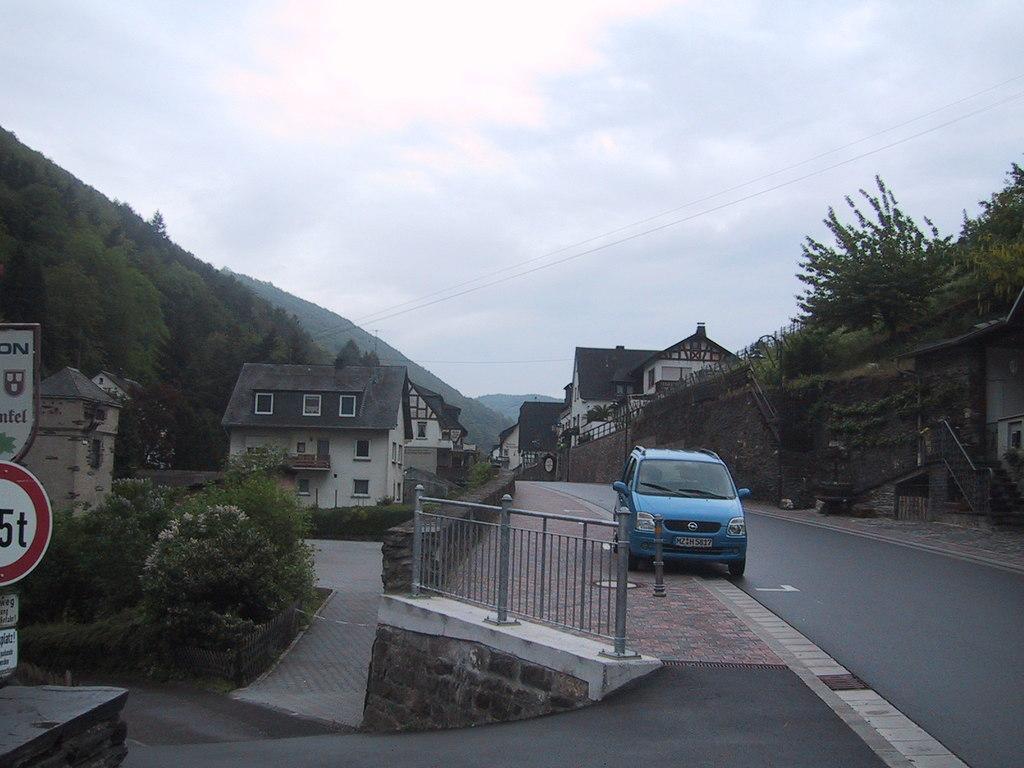In one or two sentences, can you explain what this image depicts? In the foreground, I can see a board, fence, grass, house plants and a car on the road. In the background, I can see buildings, trees, mountains, staircase, wires and the sky. This picture might be taken on the road. 